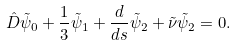<formula> <loc_0><loc_0><loc_500><loc_500>\hat { D } \tilde { \psi } _ { 0 } + \frac { 1 } { 3 } \tilde { \psi } _ { 1 } + \frac { d } { d s } \tilde { \psi } _ { 2 } + \tilde { \nu } \tilde { \psi } _ { 2 } = 0 .</formula> 